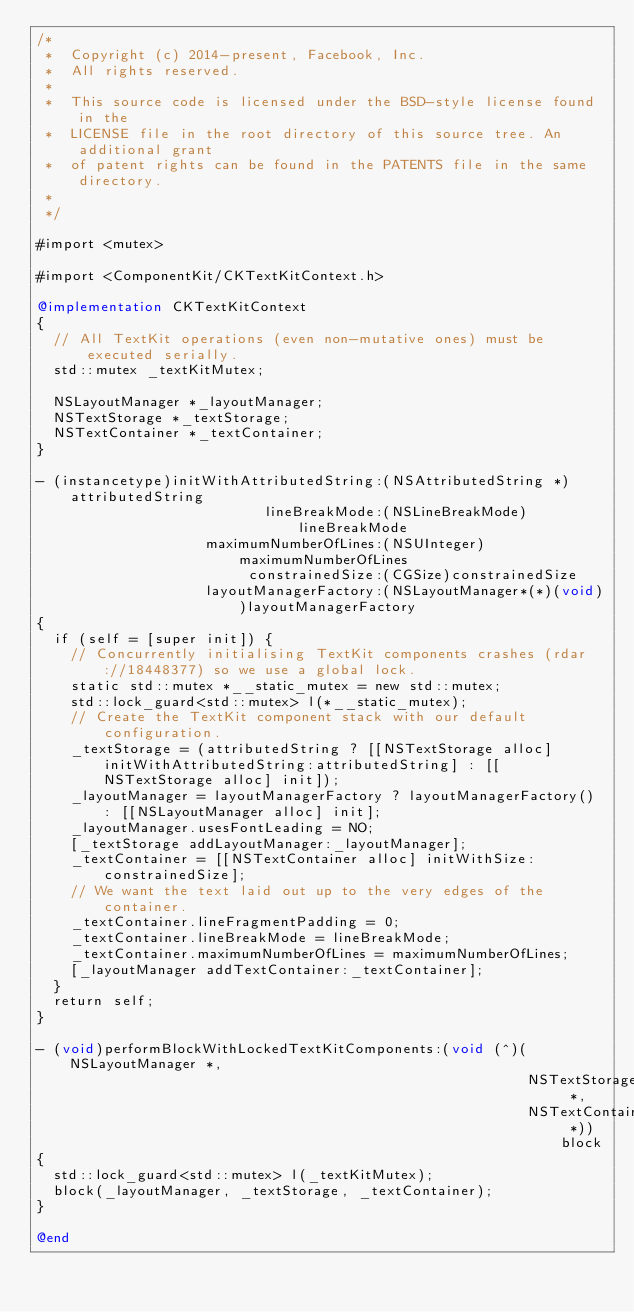Convert code to text. <code><loc_0><loc_0><loc_500><loc_500><_ObjectiveC_>/*
 *  Copyright (c) 2014-present, Facebook, Inc.
 *  All rights reserved.
 *
 *  This source code is licensed under the BSD-style license found in the
 *  LICENSE file in the root directory of this source tree. An additional grant
 *  of patent rights can be found in the PATENTS file in the same directory.
 *
 */

#import <mutex>

#import <ComponentKit/CKTextKitContext.h>

@implementation CKTextKitContext
{
  // All TextKit operations (even non-mutative ones) must be executed serially.
  std::mutex _textKitMutex;

  NSLayoutManager *_layoutManager;
  NSTextStorage *_textStorage;
  NSTextContainer *_textContainer;
}

- (instancetype)initWithAttributedString:(NSAttributedString *)attributedString
                           lineBreakMode:(NSLineBreakMode)lineBreakMode
                    maximumNumberOfLines:(NSUInteger)maximumNumberOfLines
                         constrainedSize:(CGSize)constrainedSize
                    layoutManagerFactory:(NSLayoutManager*(*)(void))layoutManagerFactory
{
  if (self = [super init]) {
    // Concurrently initialising TextKit components crashes (rdar://18448377) so we use a global lock.
    static std::mutex *__static_mutex = new std::mutex;
    std::lock_guard<std::mutex> l(*__static_mutex);
    // Create the TextKit component stack with our default configuration.
    _textStorage = (attributedString ? [[NSTextStorage alloc] initWithAttributedString:attributedString] : [[NSTextStorage alloc] init]);
    _layoutManager = layoutManagerFactory ? layoutManagerFactory() : [[NSLayoutManager alloc] init];
    _layoutManager.usesFontLeading = NO;
    [_textStorage addLayoutManager:_layoutManager];
    _textContainer = [[NSTextContainer alloc] initWithSize:constrainedSize];
    // We want the text laid out up to the very edges of the container.
    _textContainer.lineFragmentPadding = 0;
    _textContainer.lineBreakMode = lineBreakMode;
    _textContainer.maximumNumberOfLines = maximumNumberOfLines;
    [_layoutManager addTextContainer:_textContainer];
  }
  return self;
}

- (void)performBlockWithLockedTextKitComponents:(void (^)(NSLayoutManager *,
                                                          NSTextStorage *,
                                                          NSTextContainer *))block
{
  std::lock_guard<std::mutex> l(_textKitMutex);
  block(_layoutManager, _textStorage, _textContainer);
}

@end
</code> 